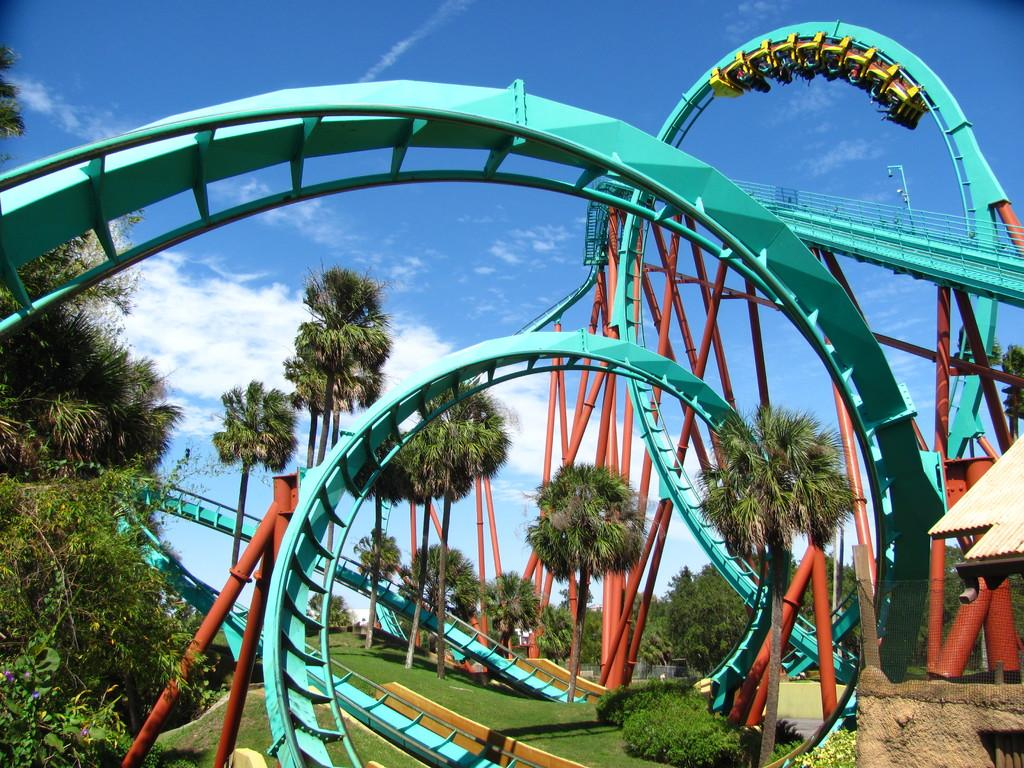What is the main subject of the image? The main subject of the image is a roller coaster. What type of surface is visible in the image? Grass is present on the surface in the image. What can be seen in the background of the image? There are trees and the sky visible in the background of the image. What type of fruit is the queen holding in the image? There is no queen or fruit present in the image; it features a roller coaster and a grassy surface. 